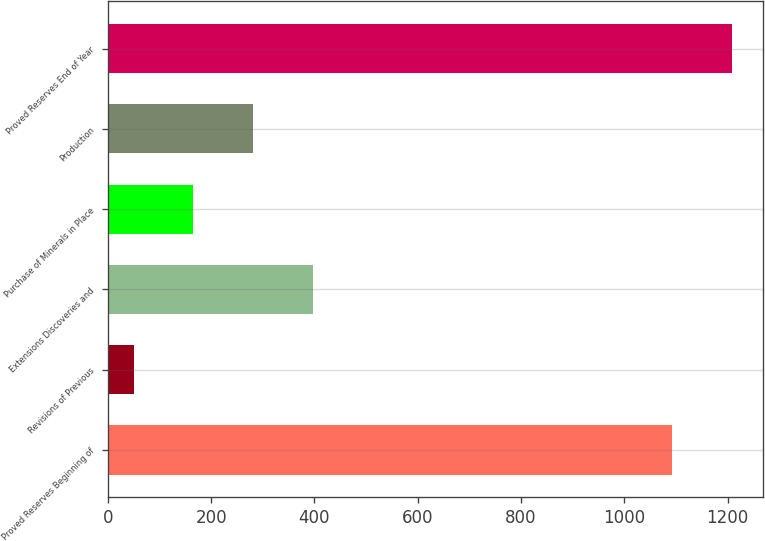<chart> <loc_0><loc_0><loc_500><loc_500><bar_chart><fcel>Proved Reserves Beginning of<fcel>Revisions of Previous<fcel>Extensions Discoveries and<fcel>Purchase of Minerals in Place<fcel>Production<fcel>Proved Reserves End of Year<nl><fcel>1092<fcel>50<fcel>397.7<fcel>165.9<fcel>281.8<fcel>1209<nl></chart> 